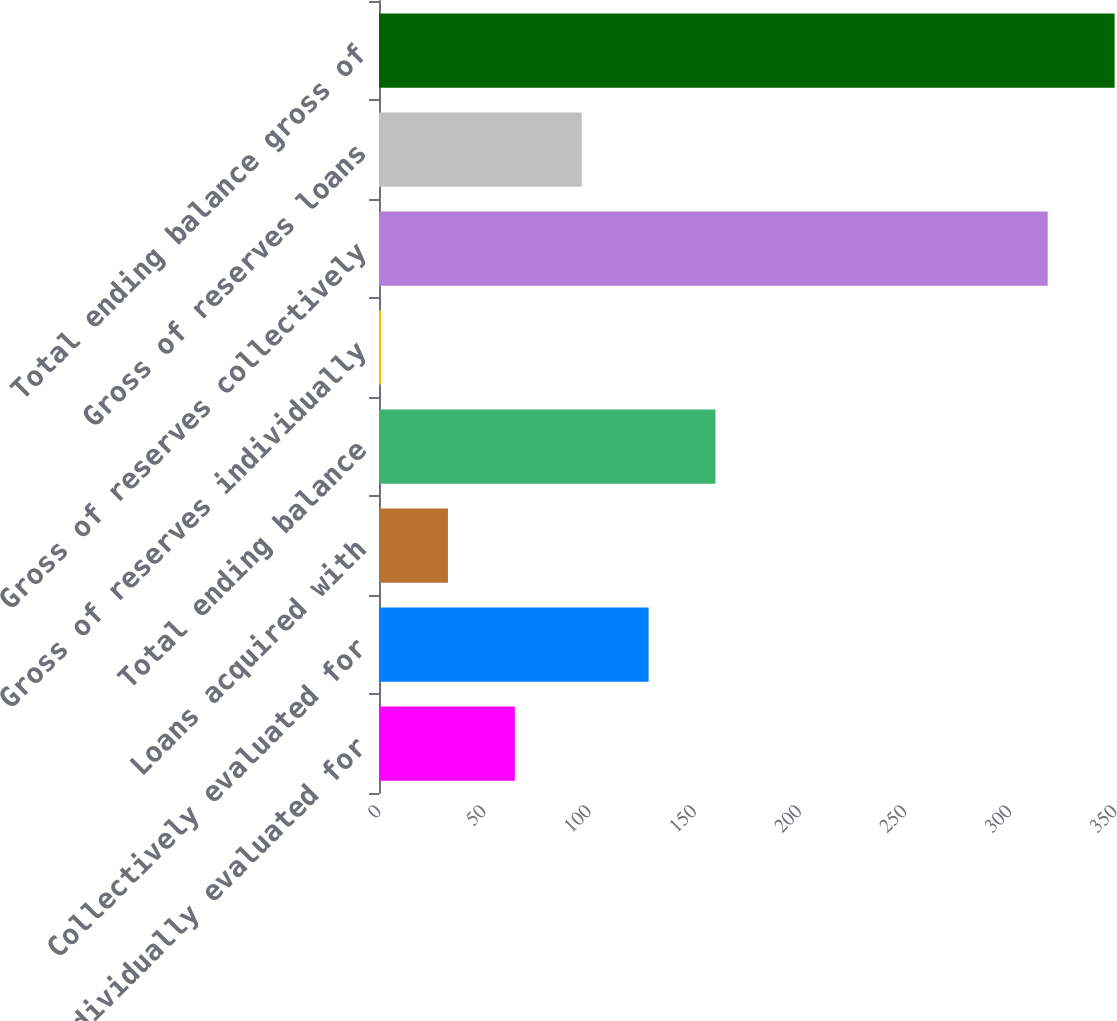Convert chart. <chart><loc_0><loc_0><loc_500><loc_500><bar_chart><fcel>Individually evaluated for<fcel>Collectively evaluated for<fcel>Loans acquired with<fcel>Total ending balance<fcel>Gross of reserves individually<fcel>Gross of reserves collectively<fcel>Gross of reserves loans<fcel>Total ending balance gross of<nl><fcel>64.6<fcel>128.2<fcel>32.8<fcel>160<fcel>1<fcel>318<fcel>96.4<fcel>349.8<nl></chart> 